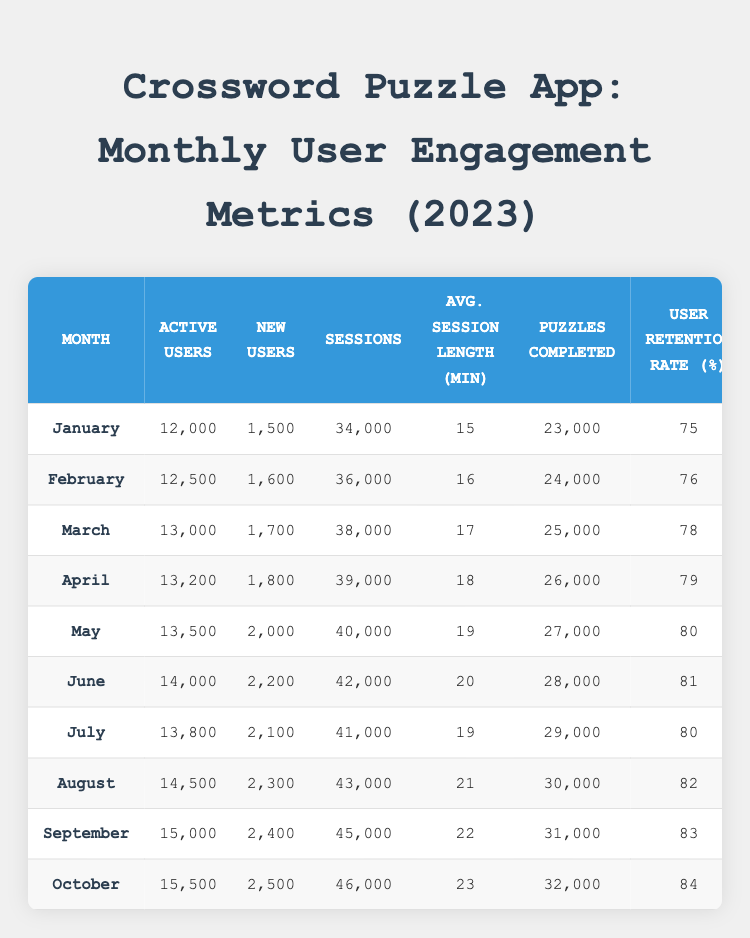What was the total number of new users in June and July 2023? Looking at the table, the number of new users in June 2023 is 2200, and in July 2023 is 2100. Adding these together gives us 2200 + 2100 = 4300.
Answer: 4300 What was the average user retention rate over the 10 months? The user retention rates for each month are: 75, 76, 78, 79, 80, 81, 80, 82, 83, 84. Adding these values gives 75 + 76 + 78 + 79 + 80 + 81 + 80 + 82 + 83 + 84 = 804. There are 10 months, so the average retention rate is 804/10 = 80.4.
Answer: 80.4 In which month were the active users at their highest? The table shows that active users peaked in October 2023 with 15500 users, which is the highest value listed among all months.
Answer: October 2023 Is the average session length longer in August than in July? In the table, the average session length for August is 21 minutes, while for July it is 19 minutes. Since 21 is greater than 19, the statement is true.
Answer: Yes What is the total number of puzzles completed from January to March 2023? The puzzles completed in January, February, and March are: 23000, 24000, and 25000 respectively. Adding these gives 23000 + 24000 + 25000 = 72000.
Answer: 72000 What was the difference in active users between January and February 2023? The active users in January 2023 are 12000, and in February 2023, they are 12500. The difference is calculated as 12500 - 12000 = 500.
Answer: 500 How many sessions were there in total from May to October 2023? The sessions data for May to October are: 40000, 41000, 42000, 43000, 44000, and 46000. Adding these gives a total of 40000 + 41000 + 42000 + 43000 + 44000 + 46000 = 256000.
Answer: 256000 In which month was the user retention rate the lowest? Referring to the table, the user retention rate was lowest in January at 75%, making it the month with the lowest retention rate.
Answer: January 2023 What is the increase in average session length from January to October 2023? The average session length in January is 15 minutes and in October is 23 minutes. The increase is calculated as 23 - 15 = 8 minutes.
Answer: 8 minutes 